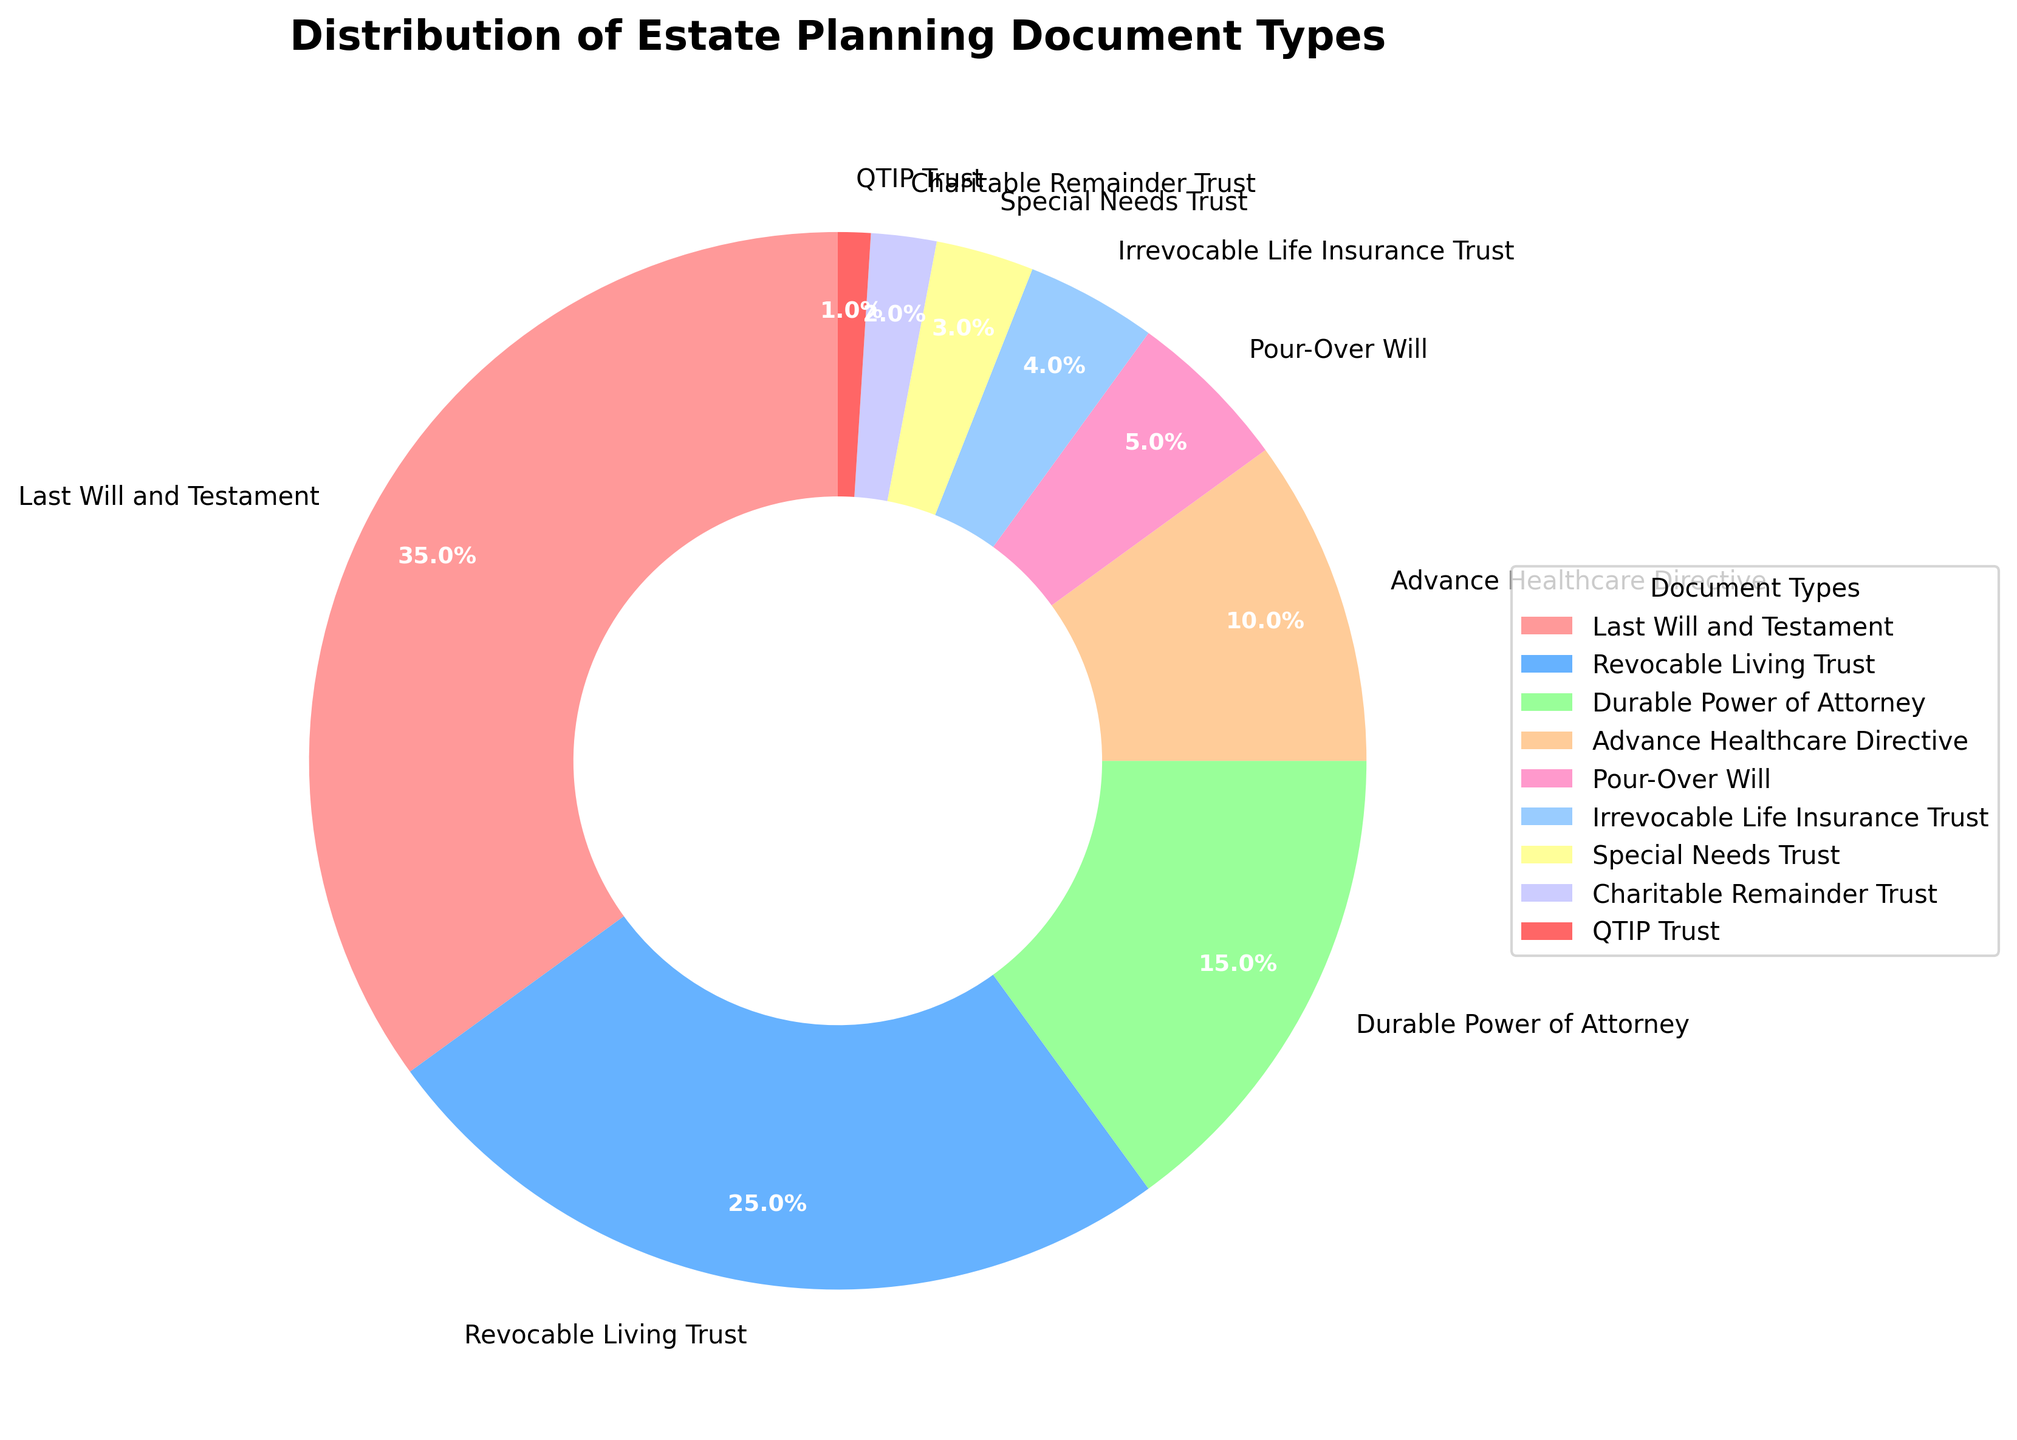What percentage of the estate planning documents are Revocable Living Trusts? According to the pie chart, the section labeled "Revocable Living Trust" represents 25% of the documents.
Answer: 25% Which document type has the smallest share, and what is its percentage? The pie chart shows that "QTIP Trust" has the smallest share, indicated by the smallest wedge, which is 1%.
Answer: QTIP Trust, 1% What is the combined percentage of Last Will and Testament and Durable Power of Attorney? The chart shows 35% for "Last Will and Testament" and 15% for "Durable Power of Attorney". Summing these percentages gives 35% + 15% = 50%.
Answer: 50% Which document types have more than 10% distribution? The chart indicates that "Last Will and Testament" at 35%, "Revocable Living Trust" at 25%, and "Durable Power of Attorney" at 15% are the document types with a distribution greater than 10%.
Answer: Last Will and Testament, Revocable Living Trust, Durable Power of Attorney How does the percentage of Special Needs Trusts compare to that of Charitable Remainder Trusts? According to the pie chart, "Special Needs Trust" is 3%, while "Charitable Remainder Trust" is 2%. Hence, Special Needs Trusts have a higher percentage than Charitable Remainder Trusts.
Answer: Special Needs Trusts have a higher percentage What is the total percentage covered by Pour-Over Will and Irrevocable Life Insurance Trust combined? The pie chart shows "Pour-Over Will" at 5% and "Irrevocable Life Insurance Trust" at 4%. Adding these together gives 5% + 4% = 9%.
Answer: 9% Which document type is represented by the blue color, and what is its percentage? The pie chart's legend shows that the section colored blue corresponds to "Revocable Living Trust," which is 25%.
Answer: Revocable Living Trust, 25% If the percentages are summed for the categories Advance Healthcare Directive, Pour-Over Will, and Irrevocable Life Insurance Trust, what is the result? The chart shows "Advance Healthcare Directive" with 10%, "Pour-Over Will" with 5%, and "Irrevocable Life Insurance Trust" with 4%. Adding these gives 10% + 5% + 4% = 19%.
Answer: 19% Are there more document types with a distribution of 5% or less, or more than 5%? From the chart, document types 5% or less are Pour-Over Will (5%), Irrevocable Life Insurance Trust (4%), Special Needs Trust (3%), Charitable Remainder Trust (2%), and QTIP Trust (1%) – a total of 5. Types more than 5% are only three: Last Will and Testament (35%), Revocable Living Trust (25%), and Durable Power of Attorney (15%). Thus, there are more document types with 5% or less.
Answer: More with 5% or less 